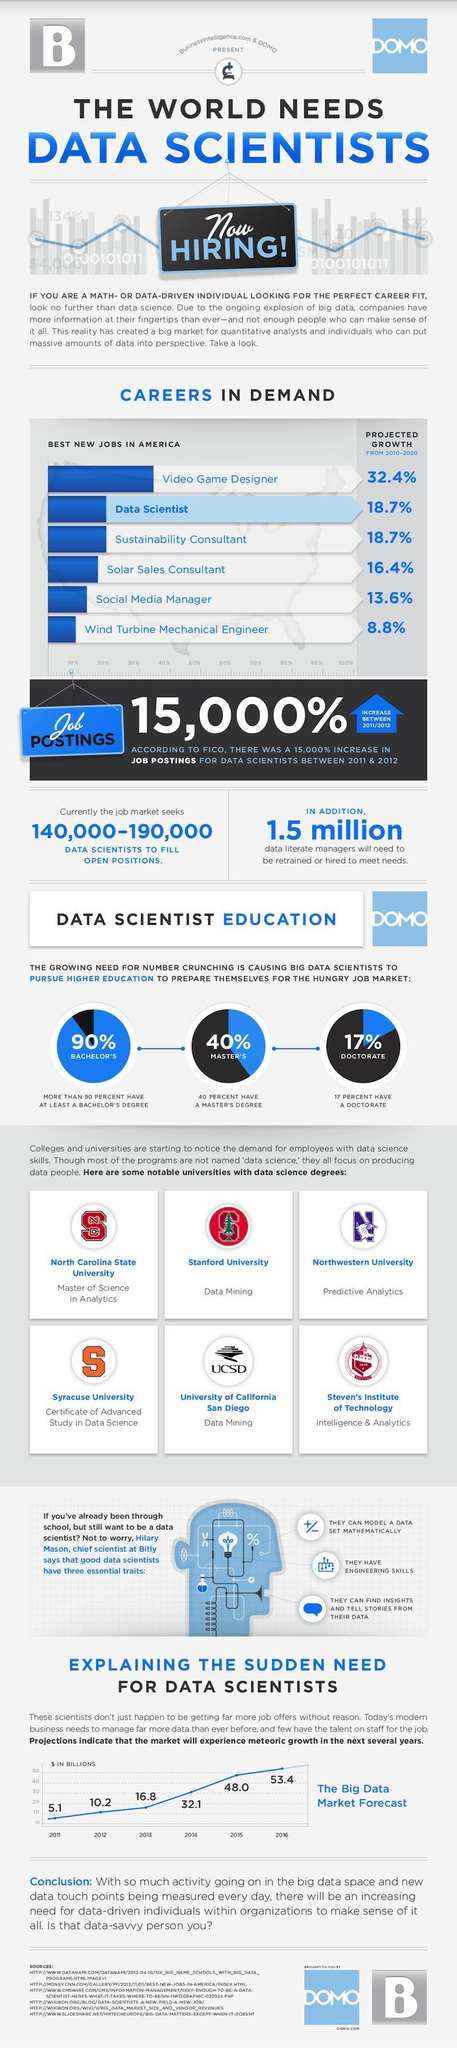How many universities are offering data mining courses?
Answer the question with a short phrase. 2 What is the percentage of big data scientists are pursuing PhD's, 17%, 40%, or 90%? 17% What was the increase in number of data scientist in billions , from 2015 to 2016? 5.4 Which other career option has the same project growth as data scientist from 2010-2020? Sustainability Consultant 